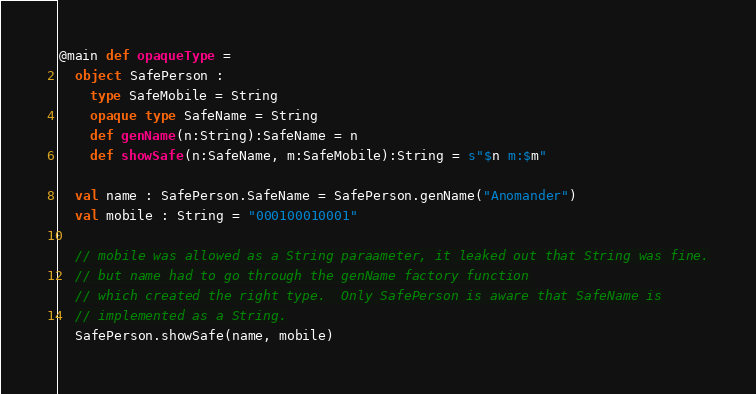Convert code to text. <code><loc_0><loc_0><loc_500><loc_500><_Scala_>
@main def opaqueType =
  object SafePerson :
    type SafeMobile = String
    opaque type SafeName = String
    def genName(n:String):SafeName = n
    def showSafe(n:SafeName, m:SafeMobile):String = s"$n m:$m"

  val name : SafePerson.SafeName = SafePerson.genName("Anomander")
  val mobile : String = "000100010001"

  // mobile was allowed as a String paraameter, it leaked out that String was fine.
  // but name had to go through the genName factory function
  // which created the right type.  Only SafePerson is aware that SafeName is
  // implemented as a String.
  SafePerson.showSafe(name, mobile)
</code> 